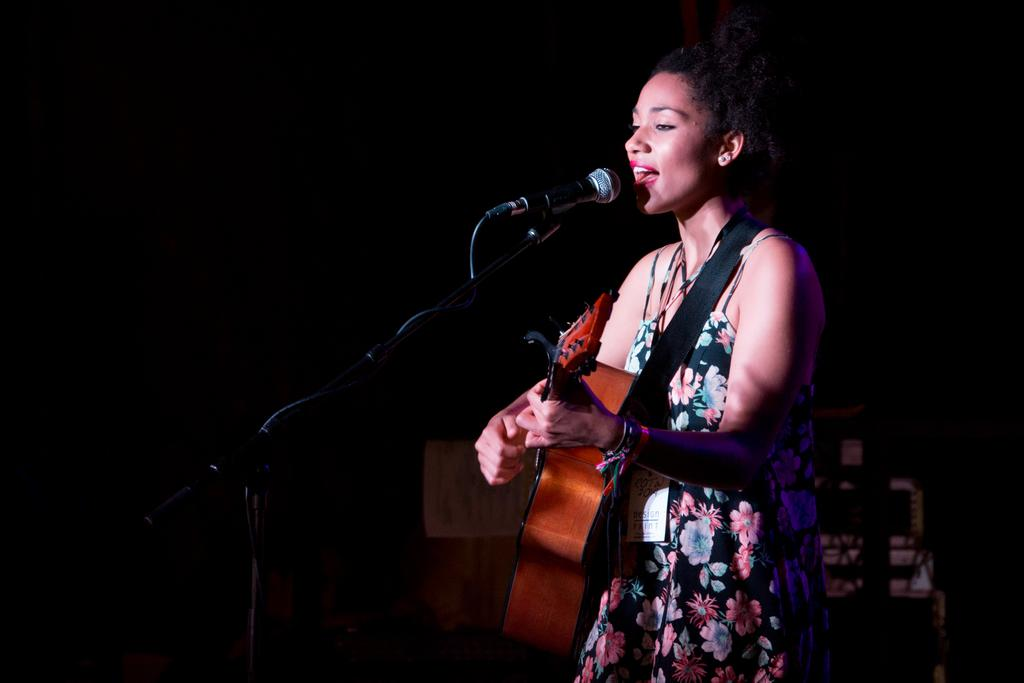What is the woman doing in the image? She is standing and playing a guitar. Is she singing in the image? Yes, she is singing a song. What can be seen on her person? She is wearing an ID card. What else is present in the image related to music? Musical instruments are visible in the background. What type of scissors can be seen cutting the lamp in the image? There are no scissors or lamps present in the image. Is there any rain visible in the image? No, there is no rain visible in the image. 